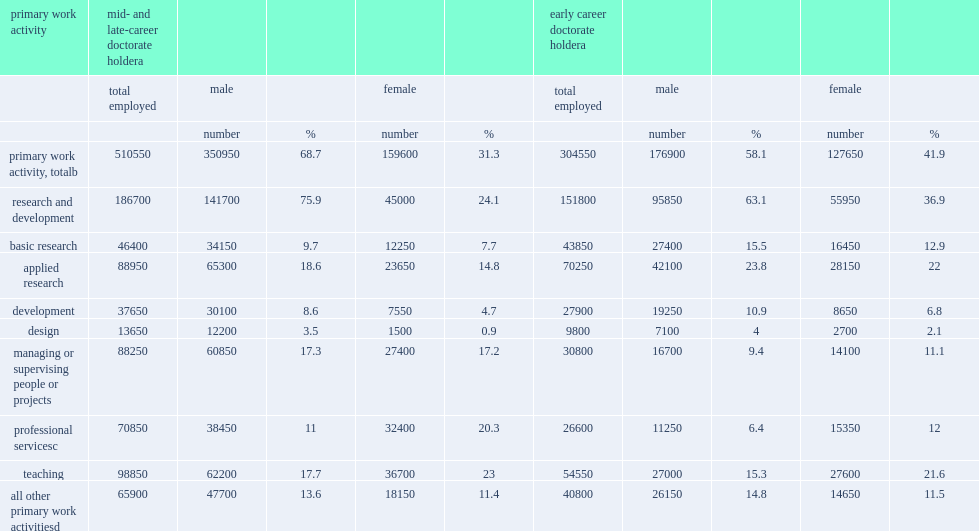In 2017, how many u.s.-trained seh early career doctorate holders who received their doctoral degree between 2006 and 2015 and were working in the united states? 304550.0. In 2017, among the nearly 305,000 u.s.-trained seh early career doctorate holders who received their doctoral degree between 2006 and 2015 and were working in the united states, how many percent were women? 41.9. Among the mid- and late-career doctorate holders with degrees earned before 2006, how many percent of people were women? 31.3. Could you parse the entire table as a dict? {'header': ['primary work activity', 'mid- and late-career doctorate holdera', '', '', '', '', 'early career doctorate holdera', '', '', '', ''], 'rows': [['', 'total employed', 'male', '', 'female', '', 'total employed', 'male', '', 'female', ''], ['', '', 'number', '%', 'number', '%', '', 'number', '%', 'number', '%'], ['primary work activity, totalb', '510550', '350950', '68.7', '159600', '31.3', '304550', '176900', '58.1', '127650', '41.9'], ['research and development', '186700', '141700', '75.9', '45000', '24.1', '151800', '95850', '63.1', '55950', '36.9'], ['basic research', '46400', '34150', '9.7', '12250', '7.7', '43850', '27400', '15.5', '16450', '12.9'], ['applied research', '88950', '65300', '18.6', '23650', '14.8', '70250', '42100', '23.8', '28150', '22'], ['development', '37650', '30100', '8.6', '7550', '4.7', '27900', '19250', '10.9', '8650', '6.8'], ['design', '13650', '12200', '3.5', '1500', '0.9', '9800', '7100', '4', '2700', '2.1'], ['managing or supervising people or projects', '88250', '60850', '17.3', '27400', '17.2', '30800', '16700', '9.4', '14100', '11.1'], ['professional servicesc', '70850', '38450', '11', '32400', '20.3', '26600', '11250', '6.4', '15350', '12'], ['teaching', '98850', '62200', '17.7', '36700', '23', '54550', '27000', '15.3', '27600', '21.6'], ['all other primary work activitiesd', '65900', '47700', '13.6', '18150', '11.4', '40800', '26150', '14.8', '14650', '11.5']]} 